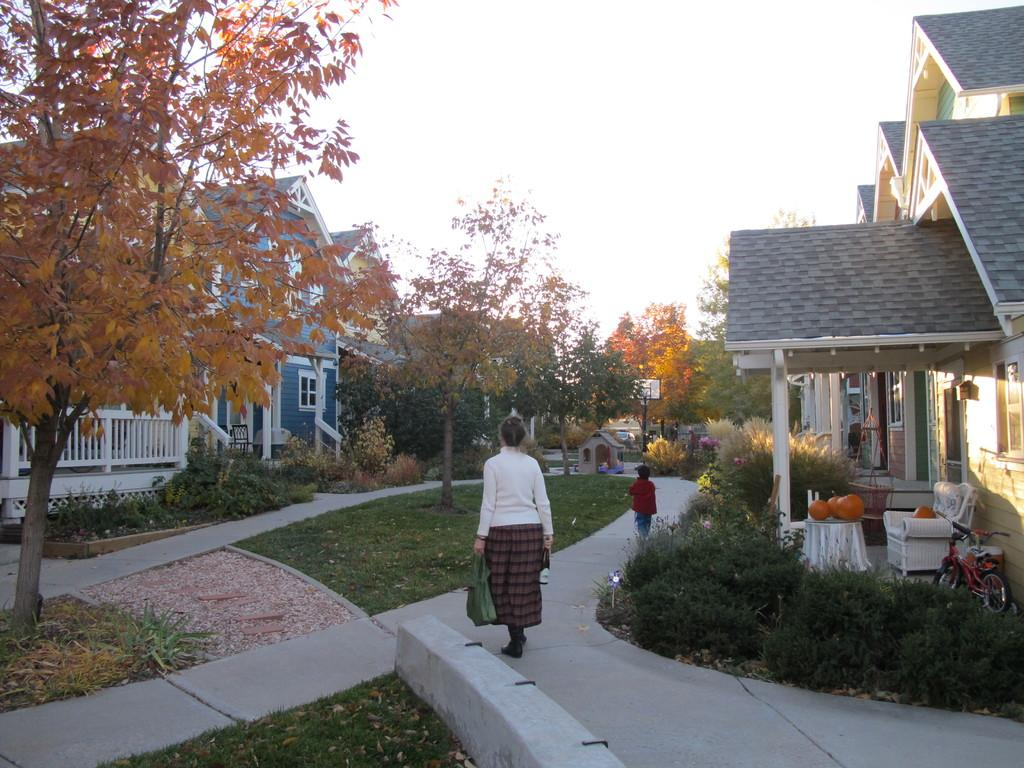What are the two persons in the image doing? The two persons in the image are walking. What type of structures can be seen in the image? There are houses in the image. What type of vegetation is present in the image? There are trees and plants in the image. What type of seating is visible in the image? There are chairs in the image. What type of transportation is present in the image? There is a bicycle in the image. What type of ground surface is visible in the image? There is grass visible in the image. What part of the natural environment is visible in the image? The sky is visible in the image. How many snails can be seen crawling on the bicycle in the image? There are no snails present in the image, so it is not possible to answer that question. What type of food is the person biting in the image? There is no person biting any food in the image. How many horses are visible in the image? There are no horses present in the image. 